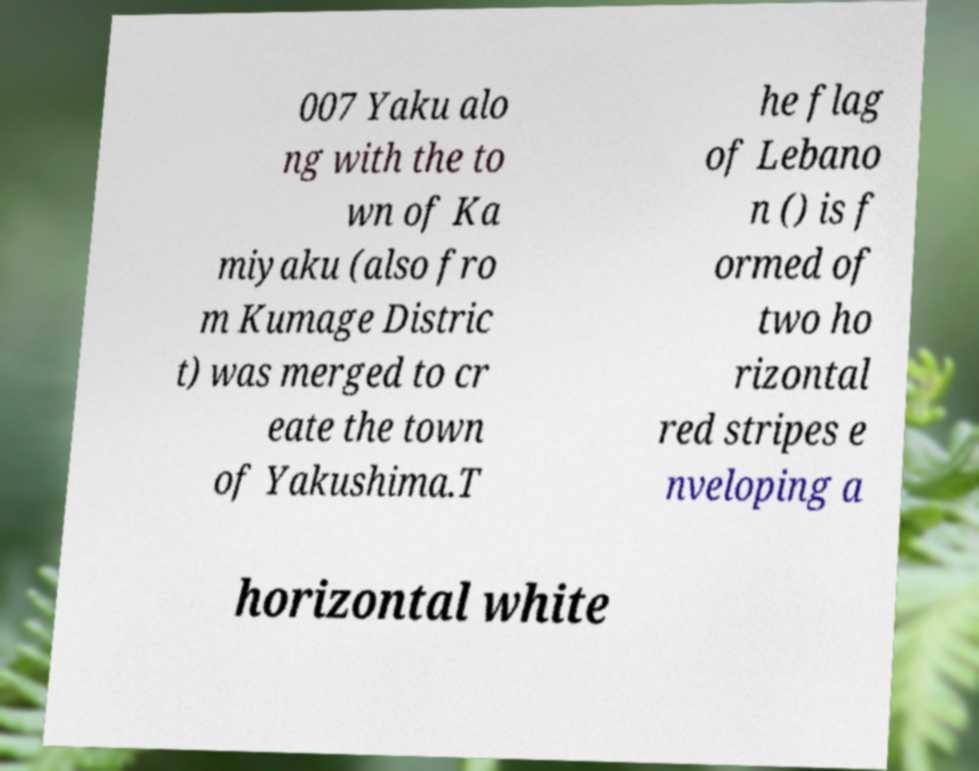For documentation purposes, I need the text within this image transcribed. Could you provide that? 007 Yaku alo ng with the to wn of Ka miyaku (also fro m Kumage Distric t) was merged to cr eate the town of Yakushima.T he flag of Lebano n () is f ormed of two ho rizontal red stripes e nveloping a horizontal white 